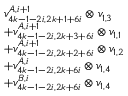Convert formula to latex. <formula><loc_0><loc_0><loc_500><loc_500>\begin{array} { r l } & { v _ { 4 k - 1 - 2 i , 2 k + 1 + 6 i } ^ { A , i + 1 } \otimes v _ { 1 , 3 } } \\ & { + v _ { 4 k - 1 - 2 i , 2 k + 3 + 6 i } ^ { A , i + 1 } \otimes v _ { 1 , 1 } } \\ & { + v _ { 4 k - 1 - 2 i , 2 k + 2 + 6 i } ^ { A , i + 1 } \otimes v _ { 1 , 2 } } \\ & { + v _ { 4 k - 1 - 2 i , 2 k + 6 i } ^ { A , i } \otimes v _ { 1 , 4 } } \\ & { + v _ { 4 k - 1 - 2 i , 2 k + 6 i } ^ { B , i } \otimes v _ { 1 , 4 } } \end{array}</formula> 